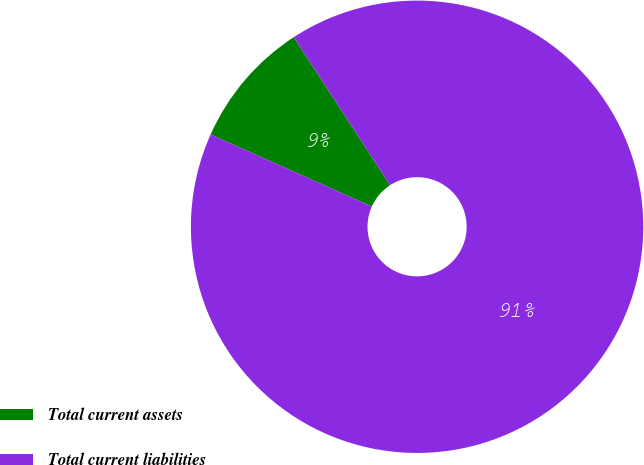<chart> <loc_0><loc_0><loc_500><loc_500><pie_chart><fcel>Total current assets<fcel>Total current liabilities<nl><fcel>9.13%<fcel>90.87%<nl></chart> 